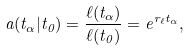<formula> <loc_0><loc_0><loc_500><loc_500>a ( t _ { \alpha } | t _ { 0 } ) = \frac { \ell ( t _ { \alpha } ) } { \ell ( t _ { 0 } ) } = e ^ { r _ { \ell } t _ { \alpha } } ,</formula> 